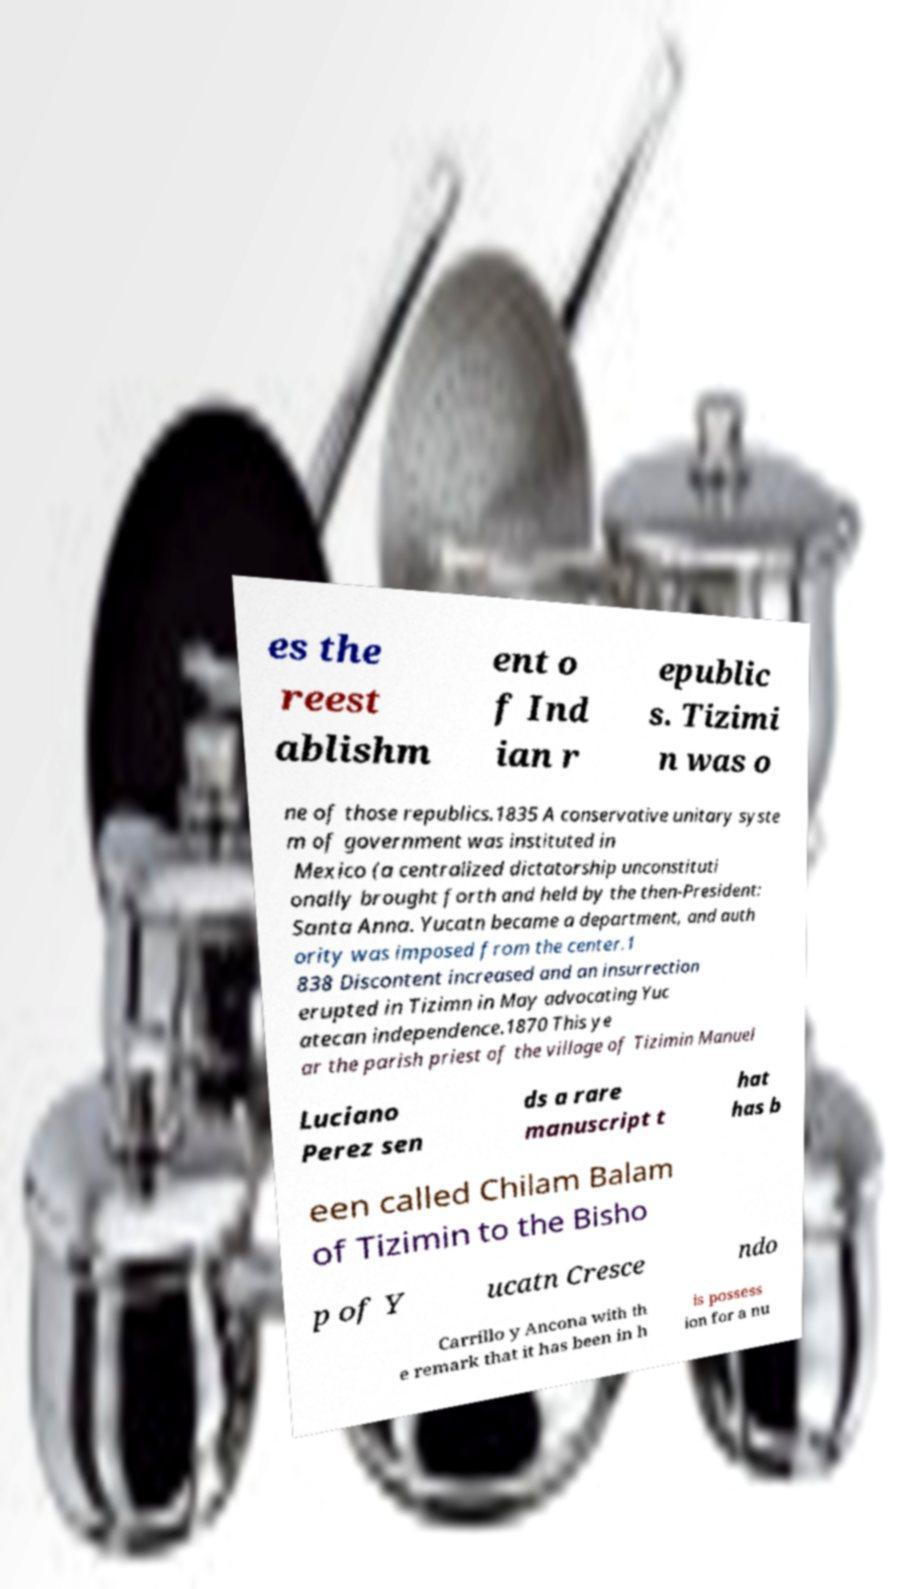Can you accurately transcribe the text from the provided image for me? es the reest ablishm ent o f Ind ian r epublic s. Tizimi n was o ne of those republics.1835 A conservative unitary syste m of government was instituted in Mexico (a centralized dictatorship unconstituti onally brought forth and held by the then-President: Santa Anna. Yucatn became a department, and auth ority was imposed from the center.1 838 Discontent increased and an insurrection erupted in Tizimn in May advocating Yuc atecan independence.1870 This ye ar the parish priest of the village of Tizimin Manuel Luciano Perez sen ds a rare manuscript t hat has b een called Chilam Balam of Tizimin to the Bisho p of Y ucatn Cresce ndo Carrillo y Ancona with th e remark that it has been in h is possess ion for a nu 